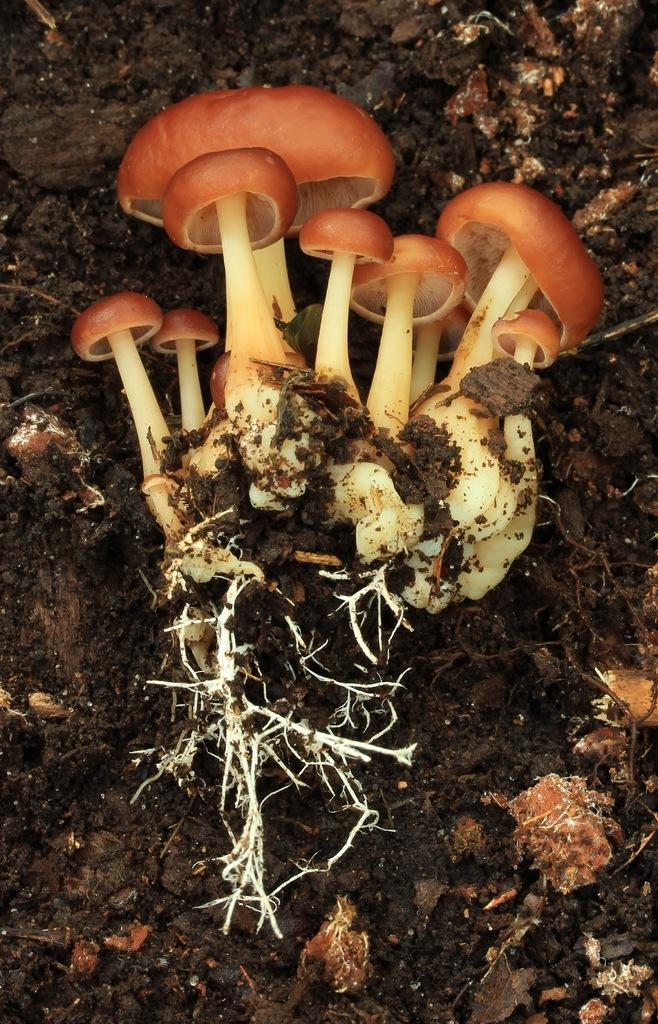What type of fungi can be seen in the image? There are mushrooms in the image. What part of the mushrooms is visible in the image? The mushrooms have roots in the image. Where are the mushrooms located in the image? The mushrooms are on a path in the image. What type of impulse can be seen affecting the growth of the mushrooms in the image? There is no impulse affecting the growth of the mushrooms in the image; they are simply growing on the path. 